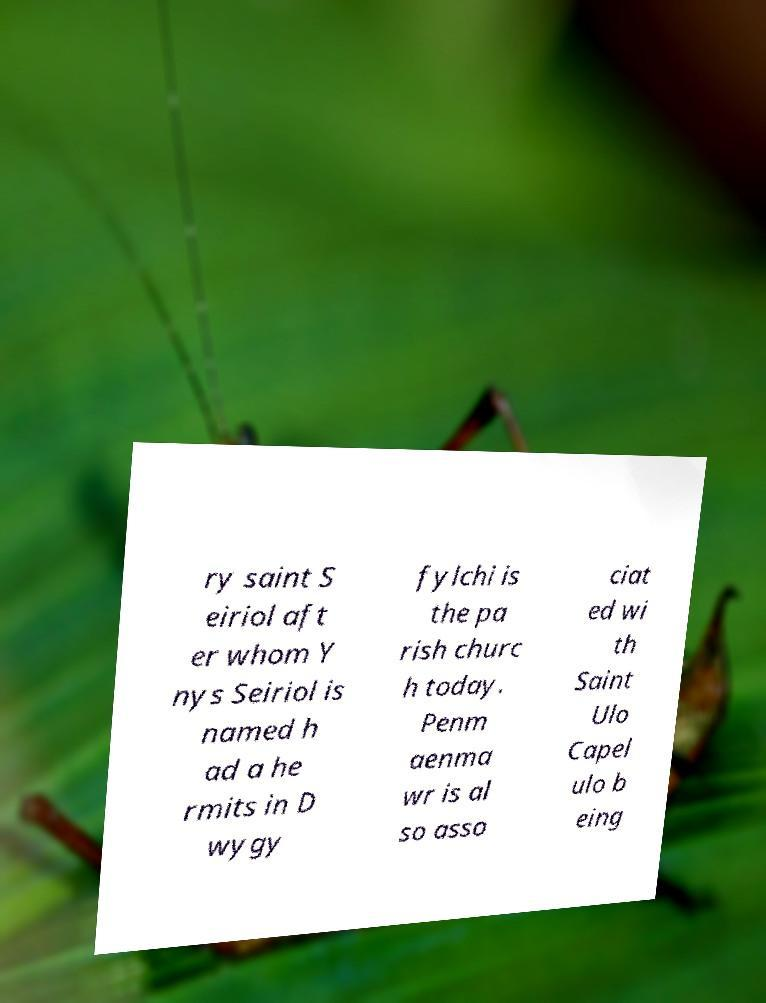Please read and relay the text visible in this image. What does it say? ry saint S eiriol aft er whom Y nys Seiriol is named h ad a he rmits in D wygy fylchi is the pa rish churc h today. Penm aenma wr is al so asso ciat ed wi th Saint Ulo Capel ulo b eing 